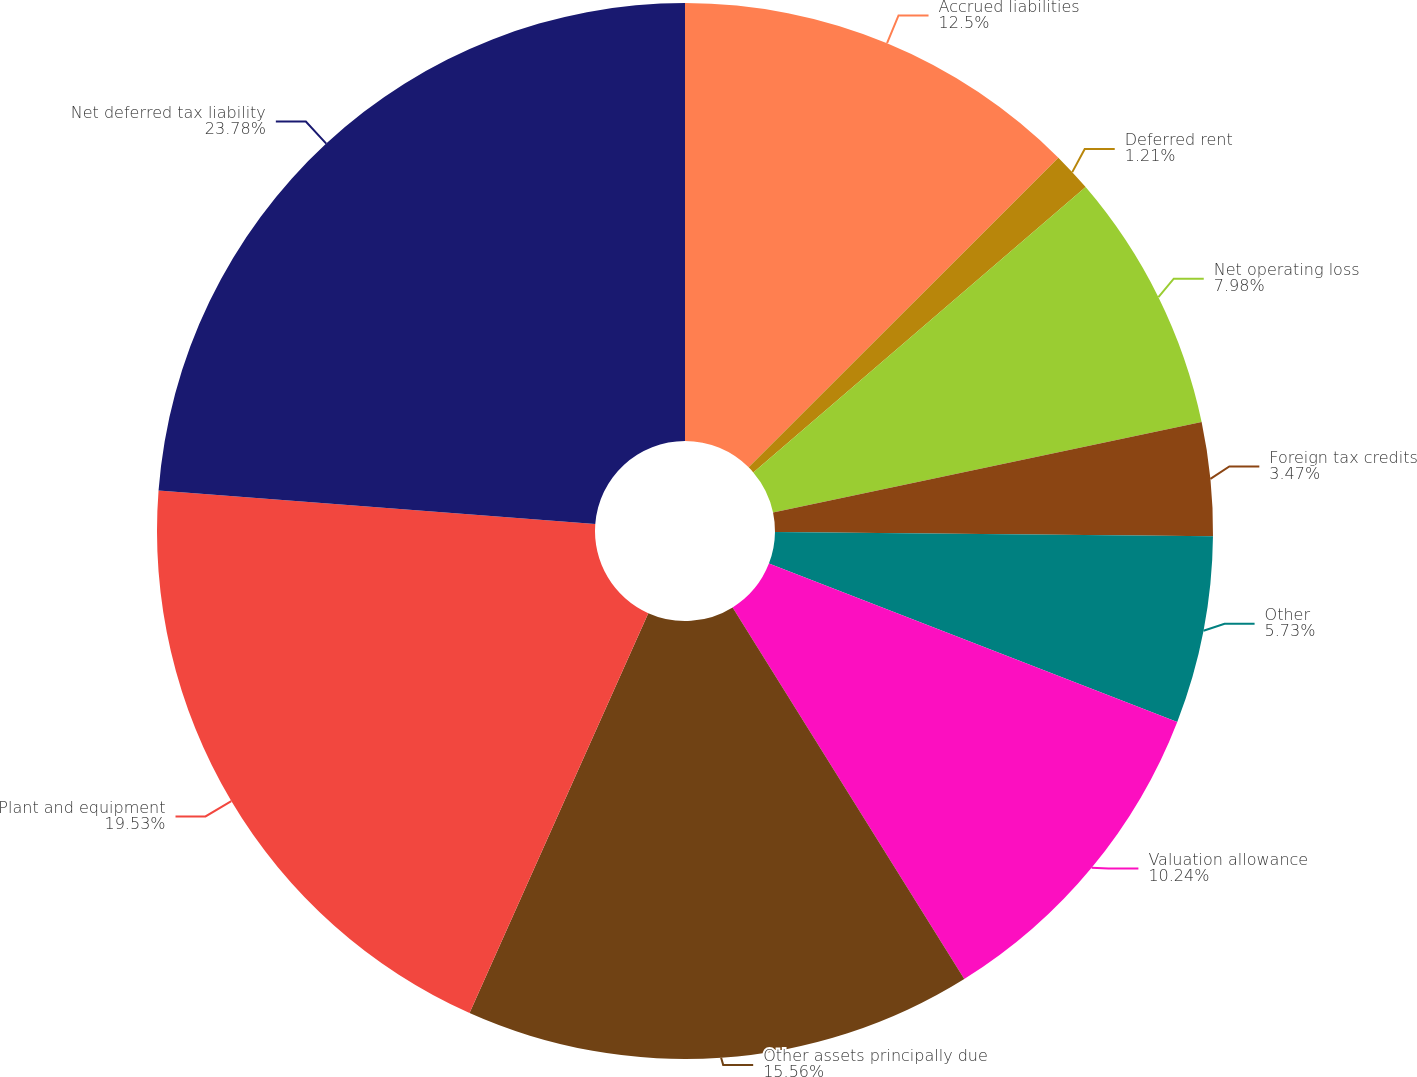Convert chart to OTSL. <chart><loc_0><loc_0><loc_500><loc_500><pie_chart><fcel>Accrued liabilities<fcel>Deferred rent<fcel>Net operating loss<fcel>Foreign tax credits<fcel>Other<fcel>Valuation allowance<fcel>Other assets principally due<fcel>Plant and equipment<fcel>Net deferred tax liability<nl><fcel>12.5%<fcel>1.21%<fcel>7.98%<fcel>3.47%<fcel>5.73%<fcel>10.24%<fcel>15.56%<fcel>19.53%<fcel>23.78%<nl></chart> 